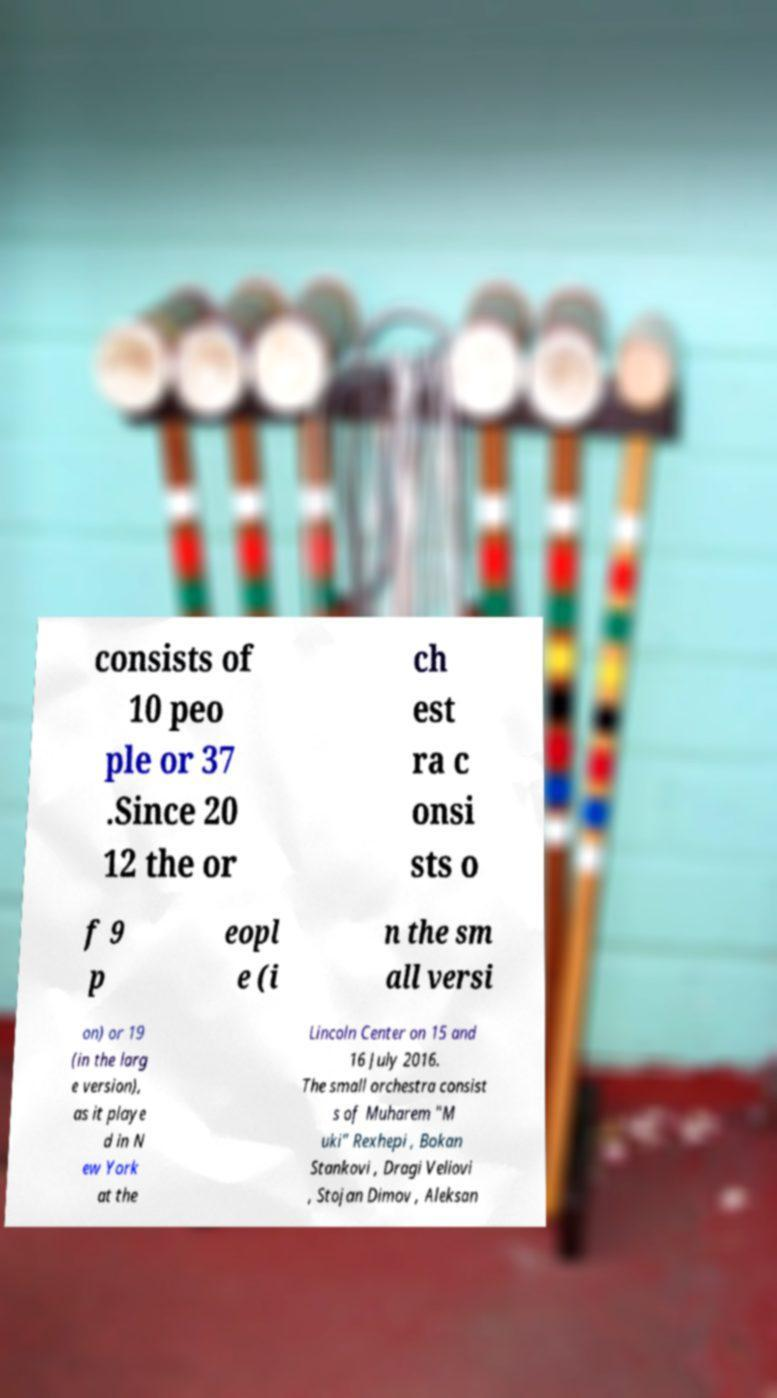Please read and relay the text visible in this image. What does it say? consists of 10 peo ple or 37 .Since 20 12 the or ch est ra c onsi sts o f 9 p eopl e (i n the sm all versi on) or 19 (in the larg e version), as it playe d in N ew York at the Lincoln Center on 15 and 16 July 2016. The small orchestra consist s of Muharem "M uki" Rexhepi , Bokan Stankovi , Dragi Veliovi , Stojan Dimov , Aleksan 